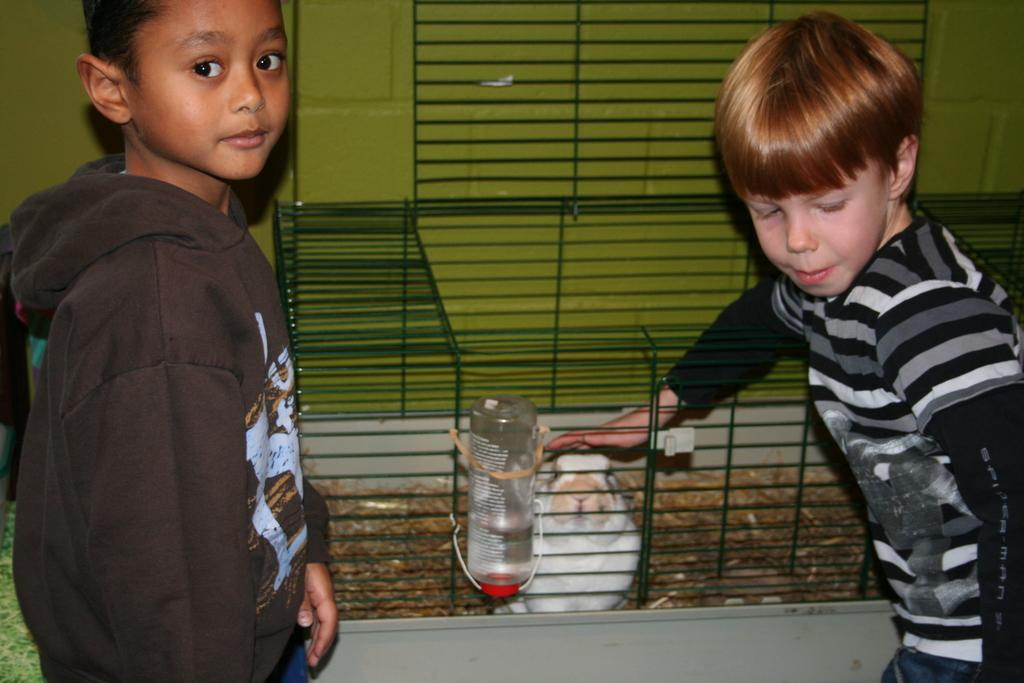How many people are in the image? There are two people in the image. What is one of the people wearing? One of the people is wearing a sweater. What can be seen in the background of the image? There is a cage, an animal, a bottle, and a wall visible in the background of the image. Can you describe the animal in the cage? Unfortunately, the specific type of animal cannot be determined from the image. What type of orange is being used as a prop in the show? There is no orange or show present in the image; it features two people, a cage, an animal, a bottle, and a wall. 